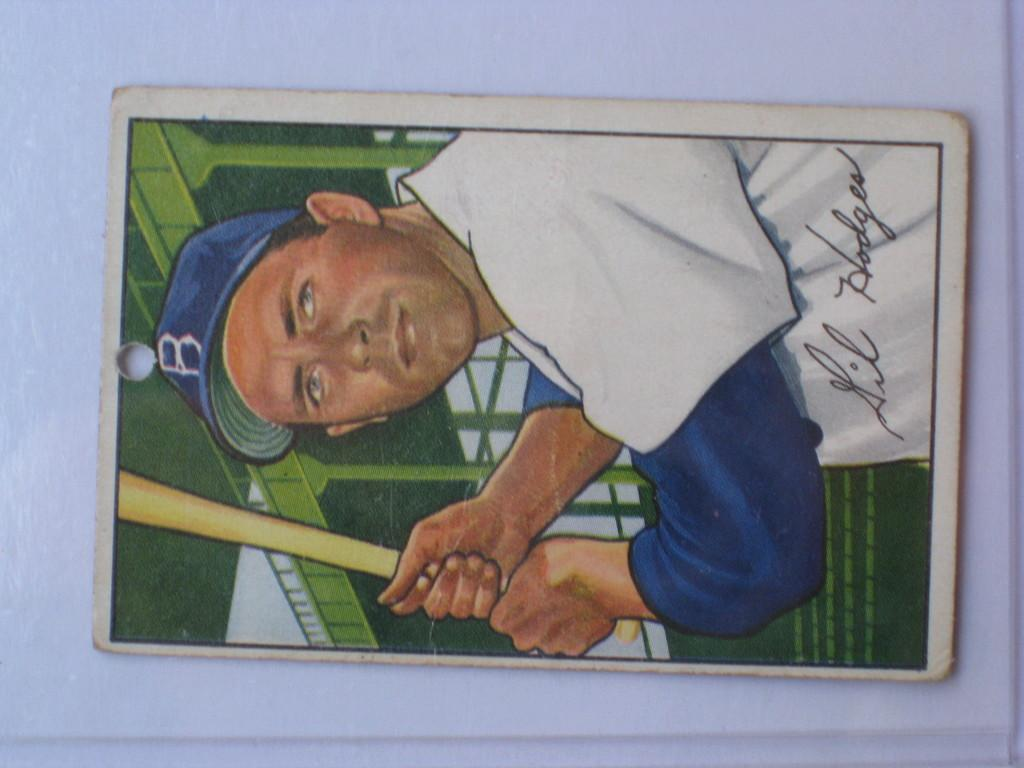What is depicted in the photograph in the image? There is a photograph of a playing card in the image. What is the player in the image doing? The player is playing rugby. What color is the shirt the player is wearing? The player is wearing a white shirt. What can be seen in the background of the image? There is a green color metal bridge in the background of the image. How many cows are present in the image? There are no cows present in the image. What type of joke is being told by the player in the image? There is no indication of a joke being told in the image; the player is focused on playing rugby. 